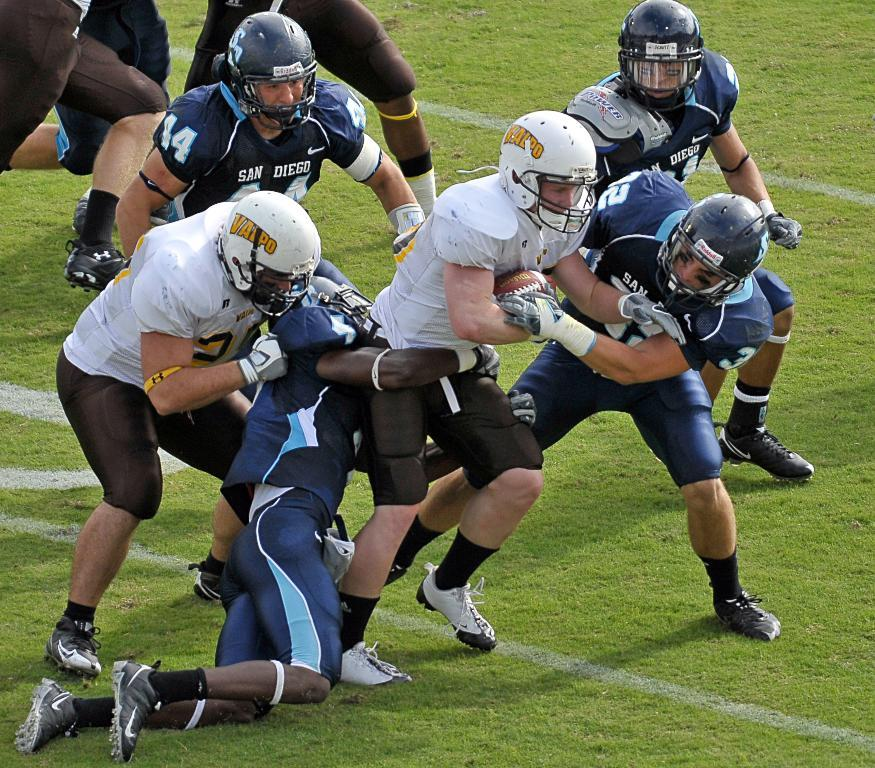Who is present in the image? There are people in the image. What are the people wearing? The people are wearing sports dress. What activity are the people engaged in? The people are playing a game. Where is the game being played? The game is being played on a ground. What object is involved in the game? Some people are holding a ball. What type of underwear is visible on the people in the image? There is no visible underwear on the people in the image, as they are wearing sports dress. Is the game being played in winter conditions in the image? The provided facts do not mention any specific season or weather conditions, so it cannot be determined if the game is being played in winter. 